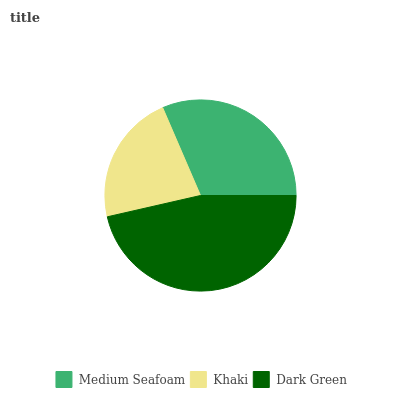Is Khaki the minimum?
Answer yes or no. Yes. Is Dark Green the maximum?
Answer yes or no. Yes. Is Dark Green the minimum?
Answer yes or no. No. Is Khaki the maximum?
Answer yes or no. No. Is Dark Green greater than Khaki?
Answer yes or no. Yes. Is Khaki less than Dark Green?
Answer yes or no. Yes. Is Khaki greater than Dark Green?
Answer yes or no. No. Is Dark Green less than Khaki?
Answer yes or no. No. Is Medium Seafoam the high median?
Answer yes or no. Yes. Is Medium Seafoam the low median?
Answer yes or no. Yes. Is Dark Green the high median?
Answer yes or no. No. Is Khaki the low median?
Answer yes or no. No. 